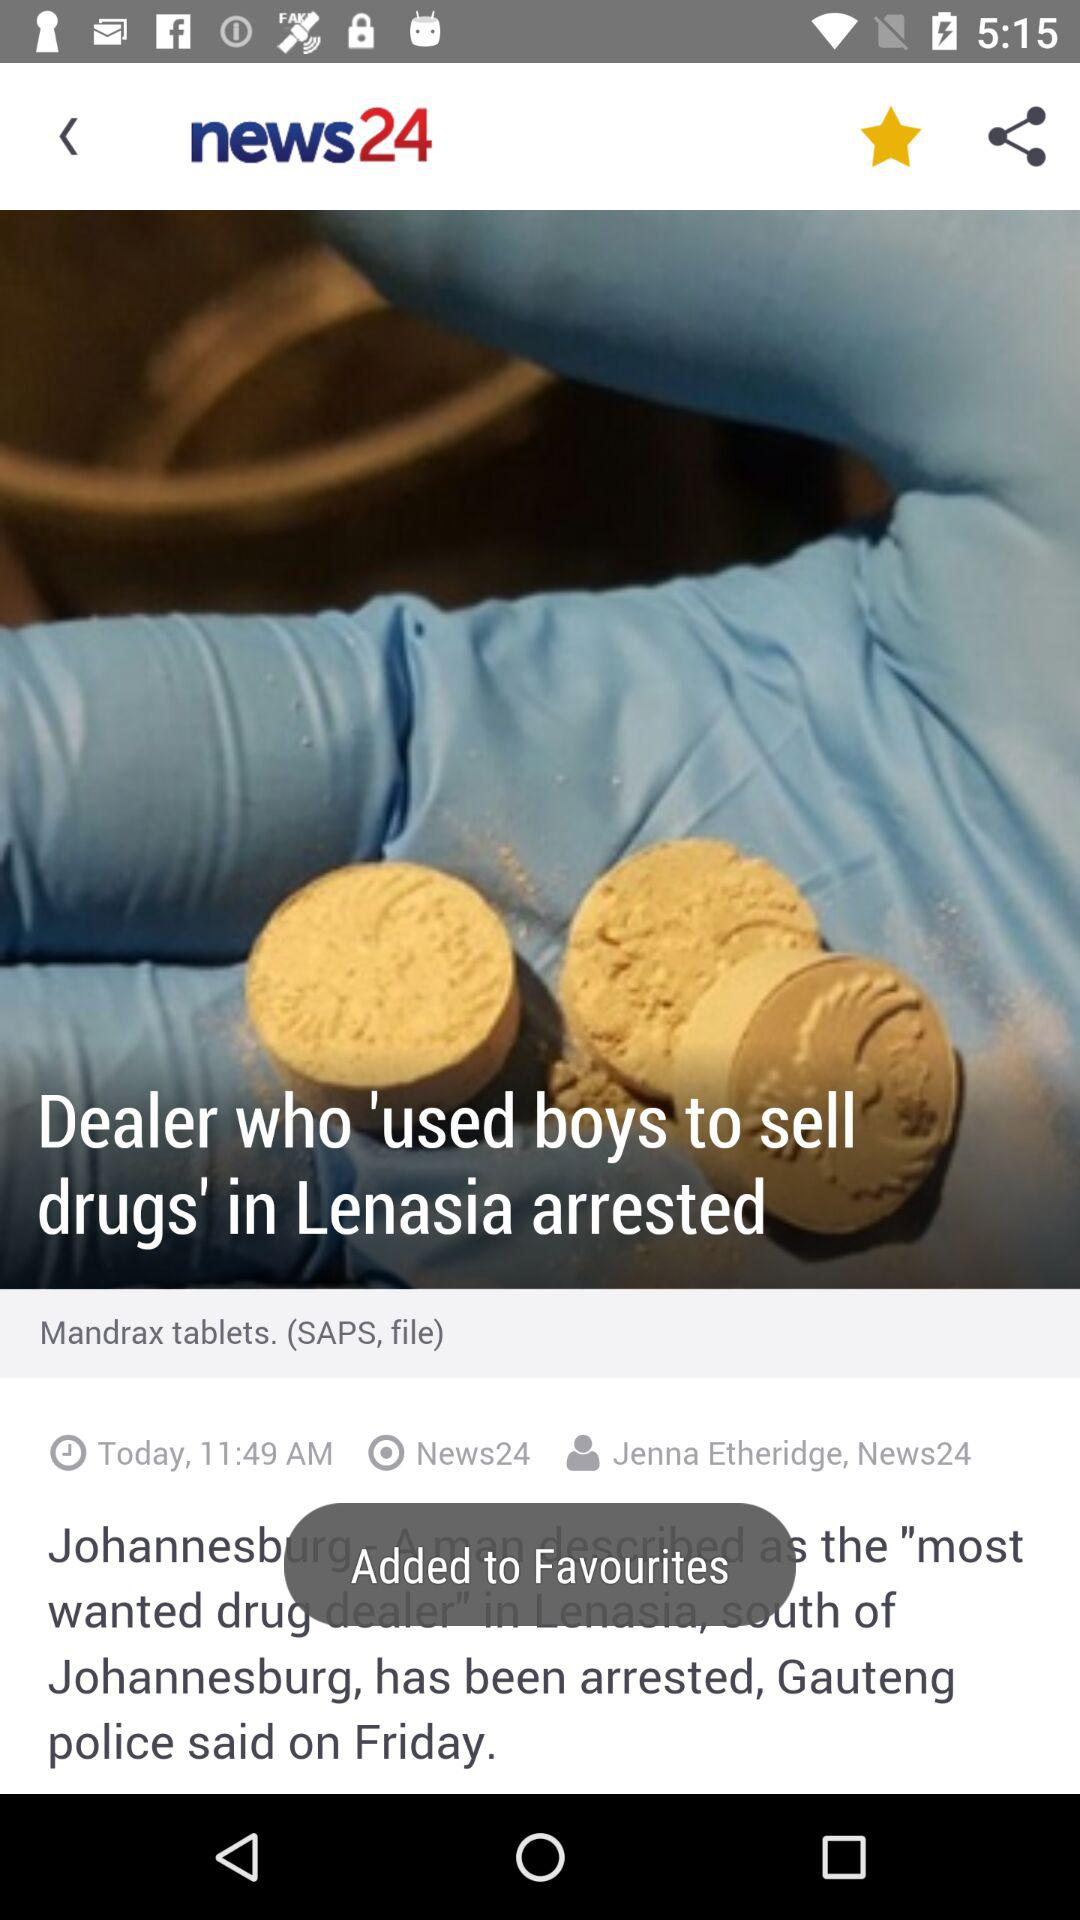Who is the author? The author is Jenna Etheridge. 